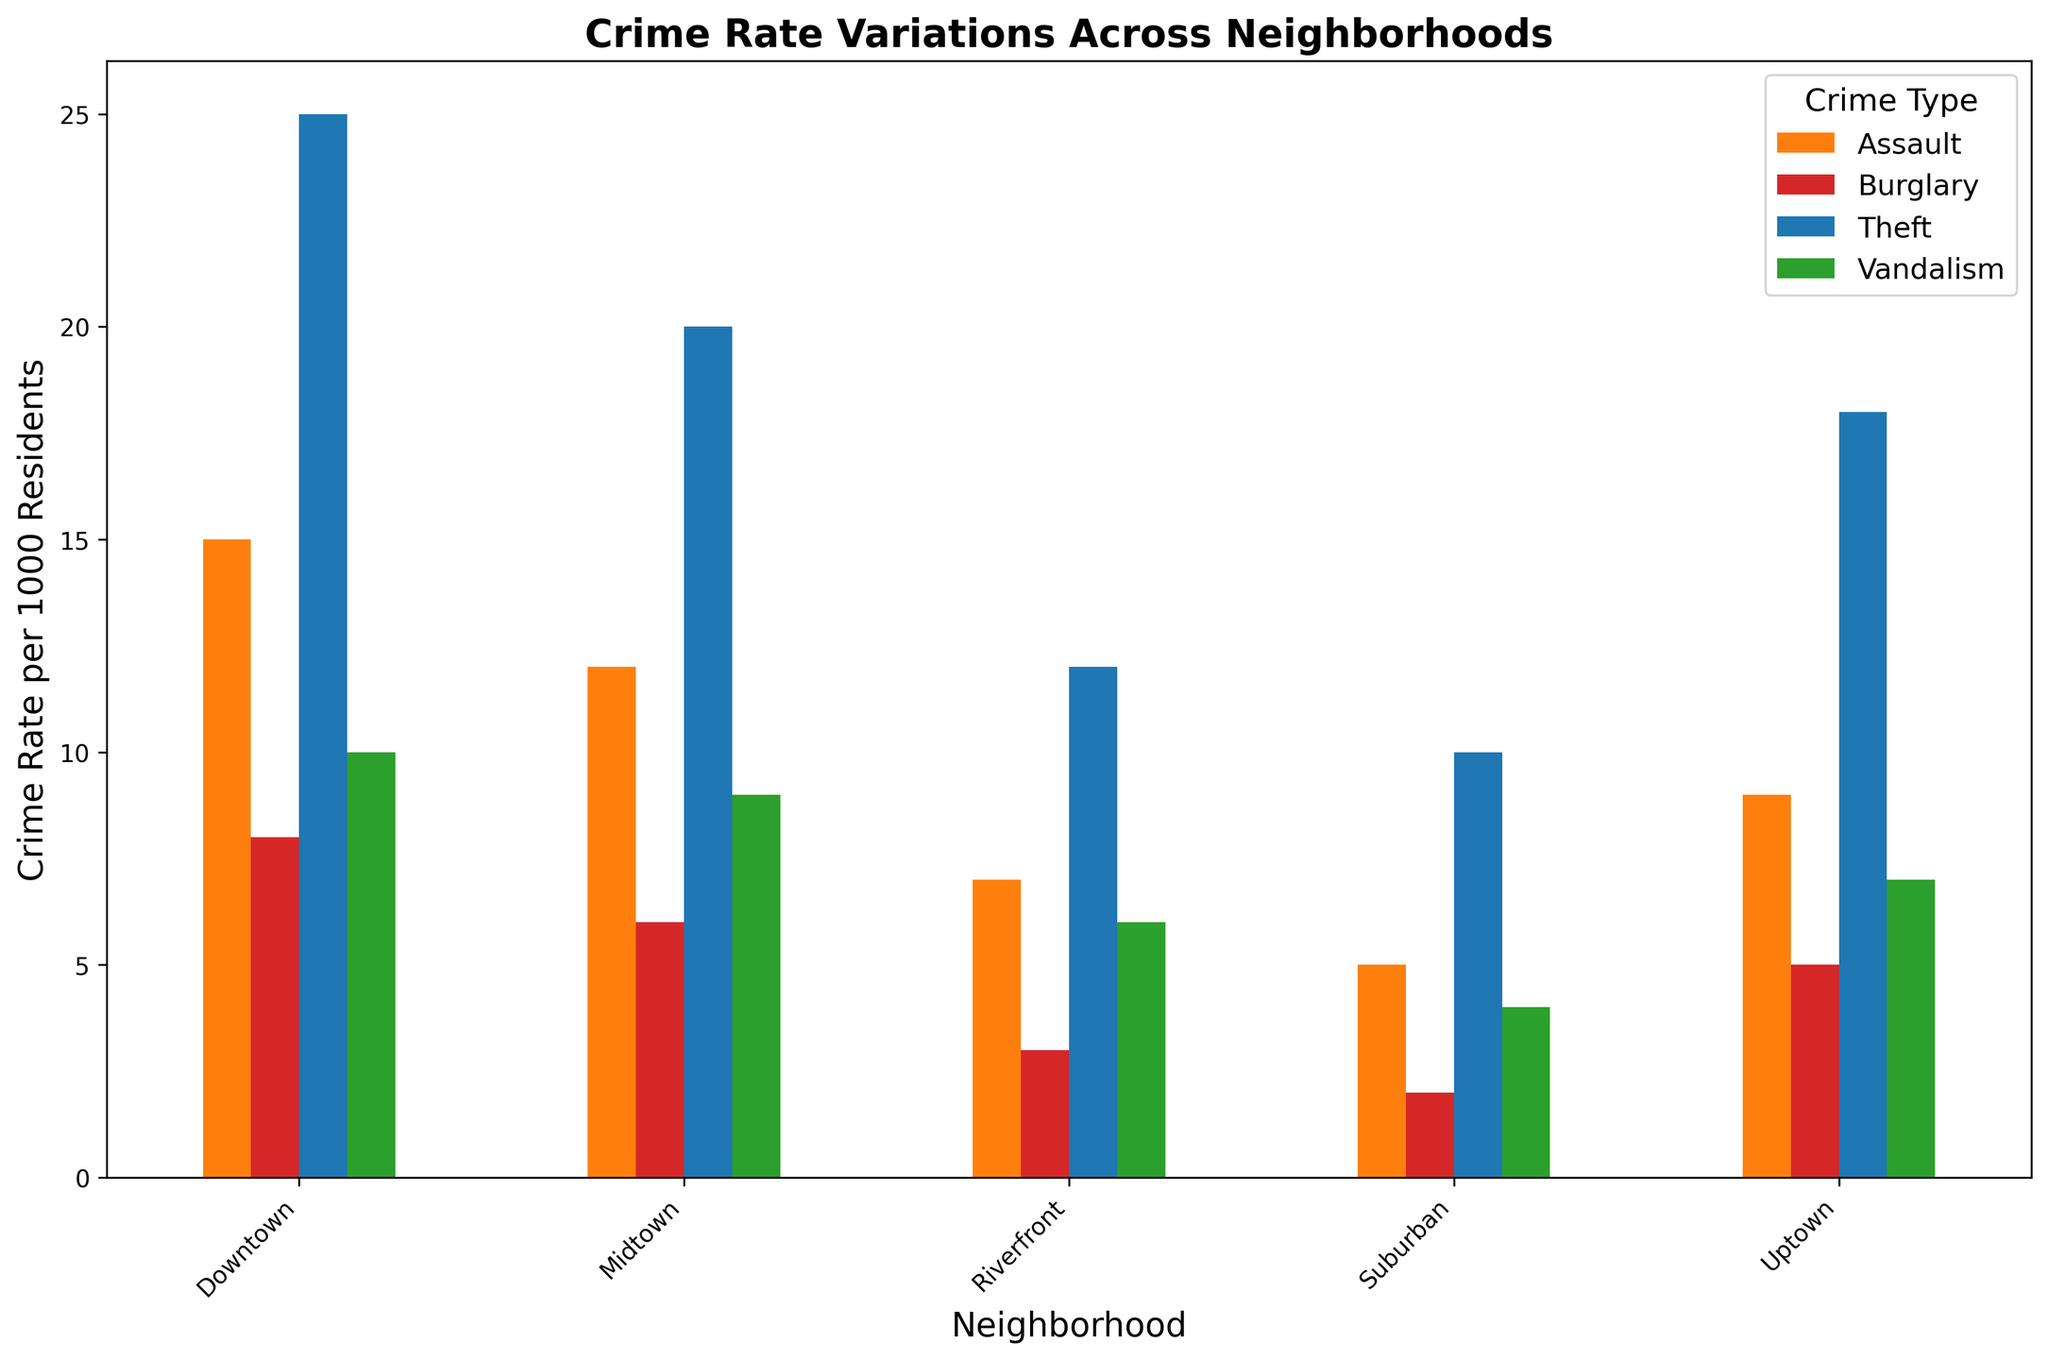What is the neighborhood with the highest rate of theft? Look at the blue bars (representing Theft) in the different neighborhoods. The blue bar is tallest in Downtown.
Answer: Downtown Which neighborhood has the lowest overall crime rate? Add up the heights of all bars for each neighborhood. Suburban's total is the smallest (10+5+4+2=21).
Answer: Suburban What's the difference in burglary rates between Downtown and Midtown? Find the heights of the red bars (representing Burglary) in both neighborhoods. Downtown has a rate of 8, Midtown has 6. The difference is 8 - 6 = 2.
Answer: 2 Which crime type has the lowest rate in Riverfront? Look at the bars for Riverfront and find the shortest one. The smallest value is the Burglary bar (3).
Answer: Burglary Compare the rate of assaults in Uptown and Riverfront. Which is higher? Look at the bars for Assault (orange) in both neighborhoods. Uptown's bar is 9 and Riverfront's is 7, so Uptown has the higher rate of assaults.
Answer: Uptown How much higher is the theft rate in Downtown compared to Suburban? Find the heights of the blue bars for both neighborhoods. Downtown's rate is 25, Suburban's is 10. The difference is 25 - 10 = 15.
Answer: 15 What is the combined rate of vandalism and burglary in Midtown? Find the heights of the green and red bars for Midtown. Vandalism is 9 and Burglary is 6. Add them up: 9 + 6 = 15.
Answer: 15 Which neighborhood has the highest rate of assaults? Look for the tallest orange bar. Downtown's Assault rate is the highest at 15.
Answer: Downtown What is the average crime rate of all four crime types in Uptown? Add the rates of all four crime types and divide by 4. (18 + 9 + 7 + 5) / 4 = 39 / 4 = 9.75.
Answer: 9.75 Is the vandalism rate higher in Midtown or Riverfront? Compare the green bars for both neighborhoods. Midtown's rate is 9, Riverfront's is 6. So, Midtown's rate is higher.
Answer: Midtown 